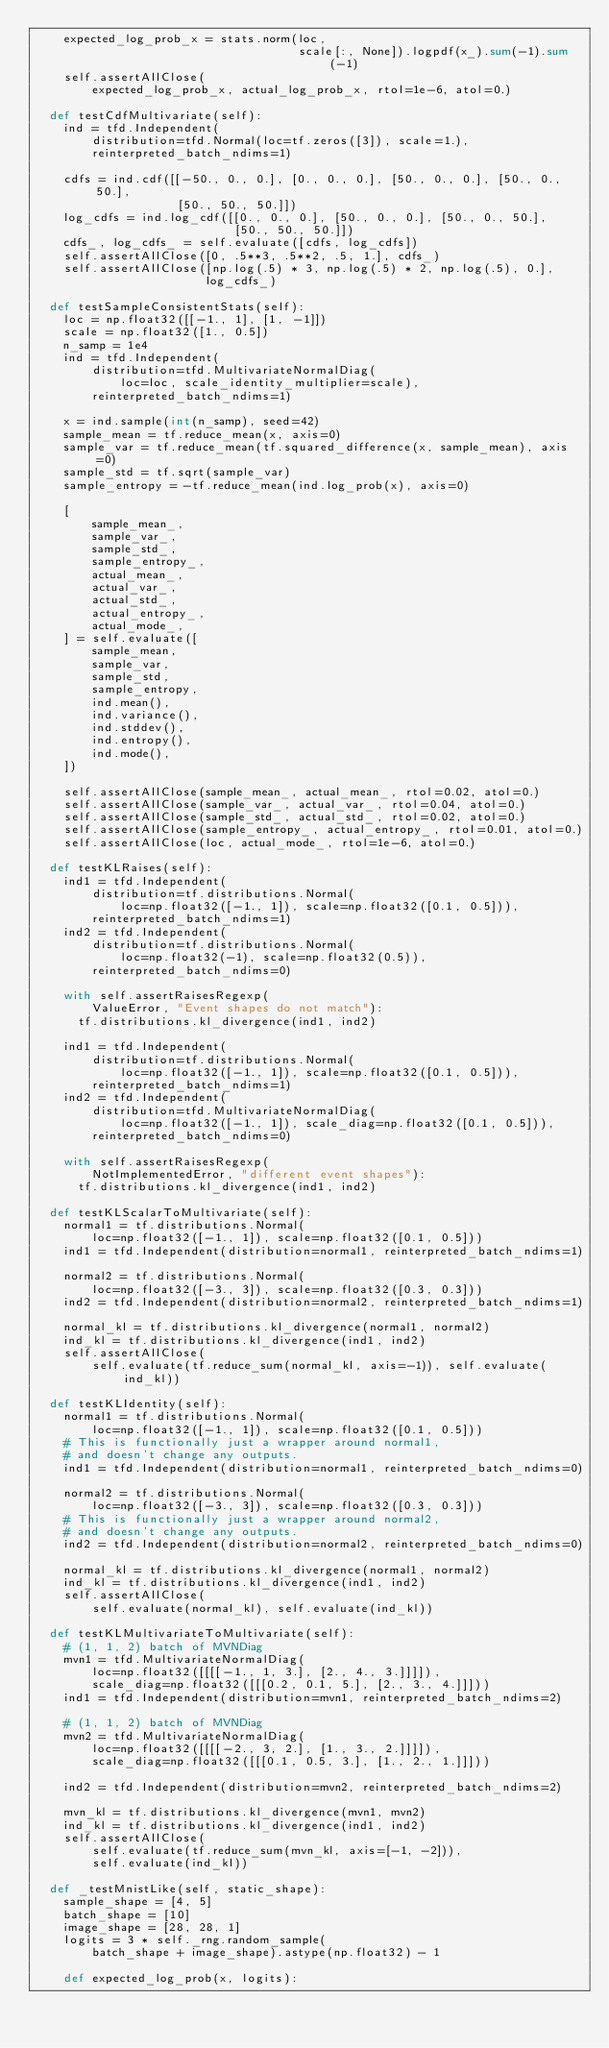Convert code to text. <code><loc_0><loc_0><loc_500><loc_500><_Python_>    expected_log_prob_x = stats.norm(loc,
                                     scale[:, None]).logpdf(x_).sum(-1).sum(-1)
    self.assertAllClose(
        expected_log_prob_x, actual_log_prob_x, rtol=1e-6, atol=0.)

  def testCdfMultivariate(self):
    ind = tfd.Independent(
        distribution=tfd.Normal(loc=tf.zeros([3]), scale=1.),
        reinterpreted_batch_ndims=1)

    cdfs = ind.cdf([[-50., 0., 0.], [0., 0., 0.], [50., 0., 0.], [50., 0., 50.],
                    [50., 50., 50.]])
    log_cdfs = ind.log_cdf([[0., 0., 0.], [50., 0., 0.], [50., 0., 50.],
                            [50., 50., 50.]])
    cdfs_, log_cdfs_ = self.evaluate([cdfs, log_cdfs])
    self.assertAllClose([0, .5**3, .5**2, .5, 1.], cdfs_)
    self.assertAllClose([np.log(.5) * 3, np.log(.5) * 2, np.log(.5), 0.],
                        log_cdfs_)

  def testSampleConsistentStats(self):
    loc = np.float32([[-1., 1], [1, -1]])
    scale = np.float32([1., 0.5])
    n_samp = 1e4
    ind = tfd.Independent(
        distribution=tfd.MultivariateNormalDiag(
            loc=loc, scale_identity_multiplier=scale),
        reinterpreted_batch_ndims=1)

    x = ind.sample(int(n_samp), seed=42)
    sample_mean = tf.reduce_mean(x, axis=0)
    sample_var = tf.reduce_mean(tf.squared_difference(x, sample_mean), axis=0)
    sample_std = tf.sqrt(sample_var)
    sample_entropy = -tf.reduce_mean(ind.log_prob(x), axis=0)

    [
        sample_mean_,
        sample_var_,
        sample_std_,
        sample_entropy_,
        actual_mean_,
        actual_var_,
        actual_std_,
        actual_entropy_,
        actual_mode_,
    ] = self.evaluate([
        sample_mean,
        sample_var,
        sample_std,
        sample_entropy,
        ind.mean(),
        ind.variance(),
        ind.stddev(),
        ind.entropy(),
        ind.mode(),
    ])

    self.assertAllClose(sample_mean_, actual_mean_, rtol=0.02, atol=0.)
    self.assertAllClose(sample_var_, actual_var_, rtol=0.04, atol=0.)
    self.assertAllClose(sample_std_, actual_std_, rtol=0.02, atol=0.)
    self.assertAllClose(sample_entropy_, actual_entropy_, rtol=0.01, atol=0.)
    self.assertAllClose(loc, actual_mode_, rtol=1e-6, atol=0.)

  def testKLRaises(self):
    ind1 = tfd.Independent(
        distribution=tf.distributions.Normal(
            loc=np.float32([-1., 1]), scale=np.float32([0.1, 0.5])),
        reinterpreted_batch_ndims=1)
    ind2 = tfd.Independent(
        distribution=tf.distributions.Normal(
            loc=np.float32(-1), scale=np.float32(0.5)),
        reinterpreted_batch_ndims=0)

    with self.assertRaisesRegexp(
        ValueError, "Event shapes do not match"):
      tf.distributions.kl_divergence(ind1, ind2)

    ind1 = tfd.Independent(
        distribution=tf.distributions.Normal(
            loc=np.float32([-1., 1]), scale=np.float32([0.1, 0.5])),
        reinterpreted_batch_ndims=1)
    ind2 = tfd.Independent(
        distribution=tfd.MultivariateNormalDiag(
            loc=np.float32([-1., 1]), scale_diag=np.float32([0.1, 0.5])),
        reinterpreted_batch_ndims=0)

    with self.assertRaisesRegexp(
        NotImplementedError, "different event shapes"):
      tf.distributions.kl_divergence(ind1, ind2)

  def testKLScalarToMultivariate(self):
    normal1 = tf.distributions.Normal(
        loc=np.float32([-1., 1]), scale=np.float32([0.1, 0.5]))
    ind1 = tfd.Independent(distribution=normal1, reinterpreted_batch_ndims=1)

    normal2 = tf.distributions.Normal(
        loc=np.float32([-3., 3]), scale=np.float32([0.3, 0.3]))
    ind2 = tfd.Independent(distribution=normal2, reinterpreted_batch_ndims=1)

    normal_kl = tf.distributions.kl_divergence(normal1, normal2)
    ind_kl = tf.distributions.kl_divergence(ind1, ind2)
    self.assertAllClose(
        self.evaluate(tf.reduce_sum(normal_kl, axis=-1)), self.evaluate(ind_kl))

  def testKLIdentity(self):
    normal1 = tf.distributions.Normal(
        loc=np.float32([-1., 1]), scale=np.float32([0.1, 0.5]))
    # This is functionally just a wrapper around normal1,
    # and doesn't change any outputs.
    ind1 = tfd.Independent(distribution=normal1, reinterpreted_batch_ndims=0)

    normal2 = tf.distributions.Normal(
        loc=np.float32([-3., 3]), scale=np.float32([0.3, 0.3]))
    # This is functionally just a wrapper around normal2,
    # and doesn't change any outputs.
    ind2 = tfd.Independent(distribution=normal2, reinterpreted_batch_ndims=0)

    normal_kl = tf.distributions.kl_divergence(normal1, normal2)
    ind_kl = tf.distributions.kl_divergence(ind1, ind2)
    self.assertAllClose(
        self.evaluate(normal_kl), self.evaluate(ind_kl))

  def testKLMultivariateToMultivariate(self):
    # (1, 1, 2) batch of MVNDiag
    mvn1 = tfd.MultivariateNormalDiag(
        loc=np.float32([[[[-1., 1, 3.], [2., 4., 3.]]]]),
        scale_diag=np.float32([[[0.2, 0.1, 5.], [2., 3., 4.]]]))
    ind1 = tfd.Independent(distribution=mvn1, reinterpreted_batch_ndims=2)

    # (1, 1, 2) batch of MVNDiag
    mvn2 = tfd.MultivariateNormalDiag(
        loc=np.float32([[[[-2., 3, 2.], [1., 3., 2.]]]]),
        scale_diag=np.float32([[[0.1, 0.5, 3.], [1., 2., 1.]]]))

    ind2 = tfd.Independent(distribution=mvn2, reinterpreted_batch_ndims=2)

    mvn_kl = tf.distributions.kl_divergence(mvn1, mvn2)
    ind_kl = tf.distributions.kl_divergence(ind1, ind2)
    self.assertAllClose(
        self.evaluate(tf.reduce_sum(mvn_kl, axis=[-1, -2])),
        self.evaluate(ind_kl))

  def _testMnistLike(self, static_shape):
    sample_shape = [4, 5]
    batch_shape = [10]
    image_shape = [28, 28, 1]
    logits = 3 * self._rng.random_sample(
        batch_shape + image_shape).astype(np.float32) - 1

    def expected_log_prob(x, logits):</code> 